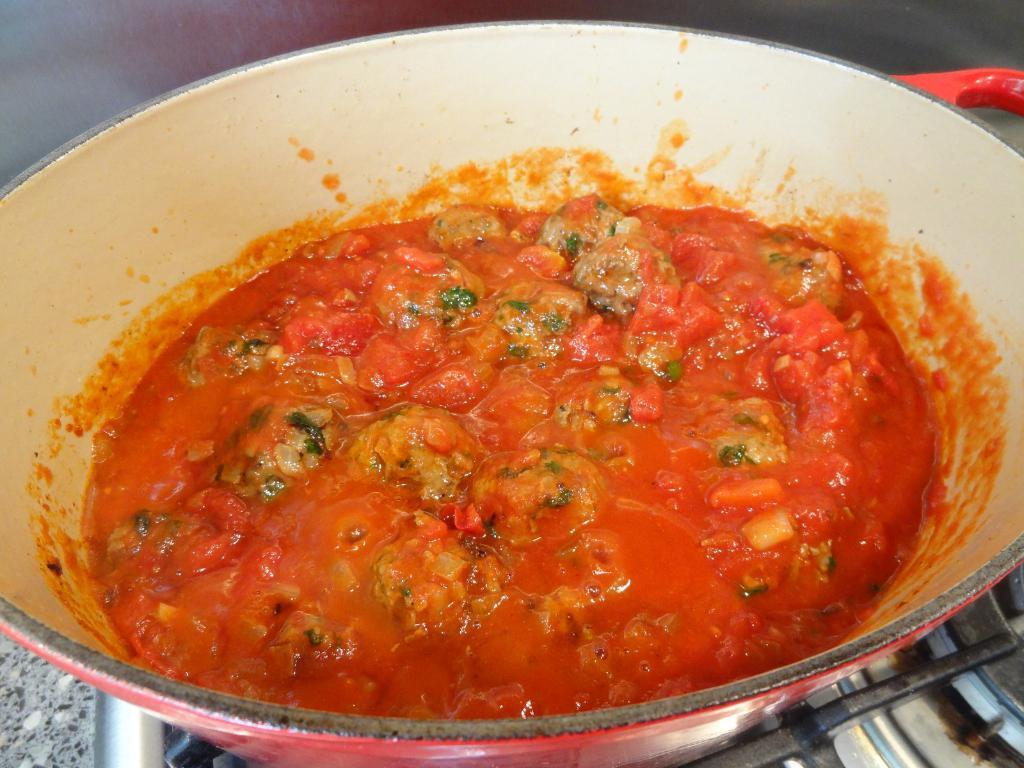What is the main subject of the image? There is a food item in the image. How is the food item contained or presented? The food item is in a bowl. Where is the bowl placed in the image? The bowl is placed on a gas stove. What type of ball can be seen bouncing on the gas stove in the image? There is no ball present in the image, and the gas stove is not being used for any activity involving a ball. 